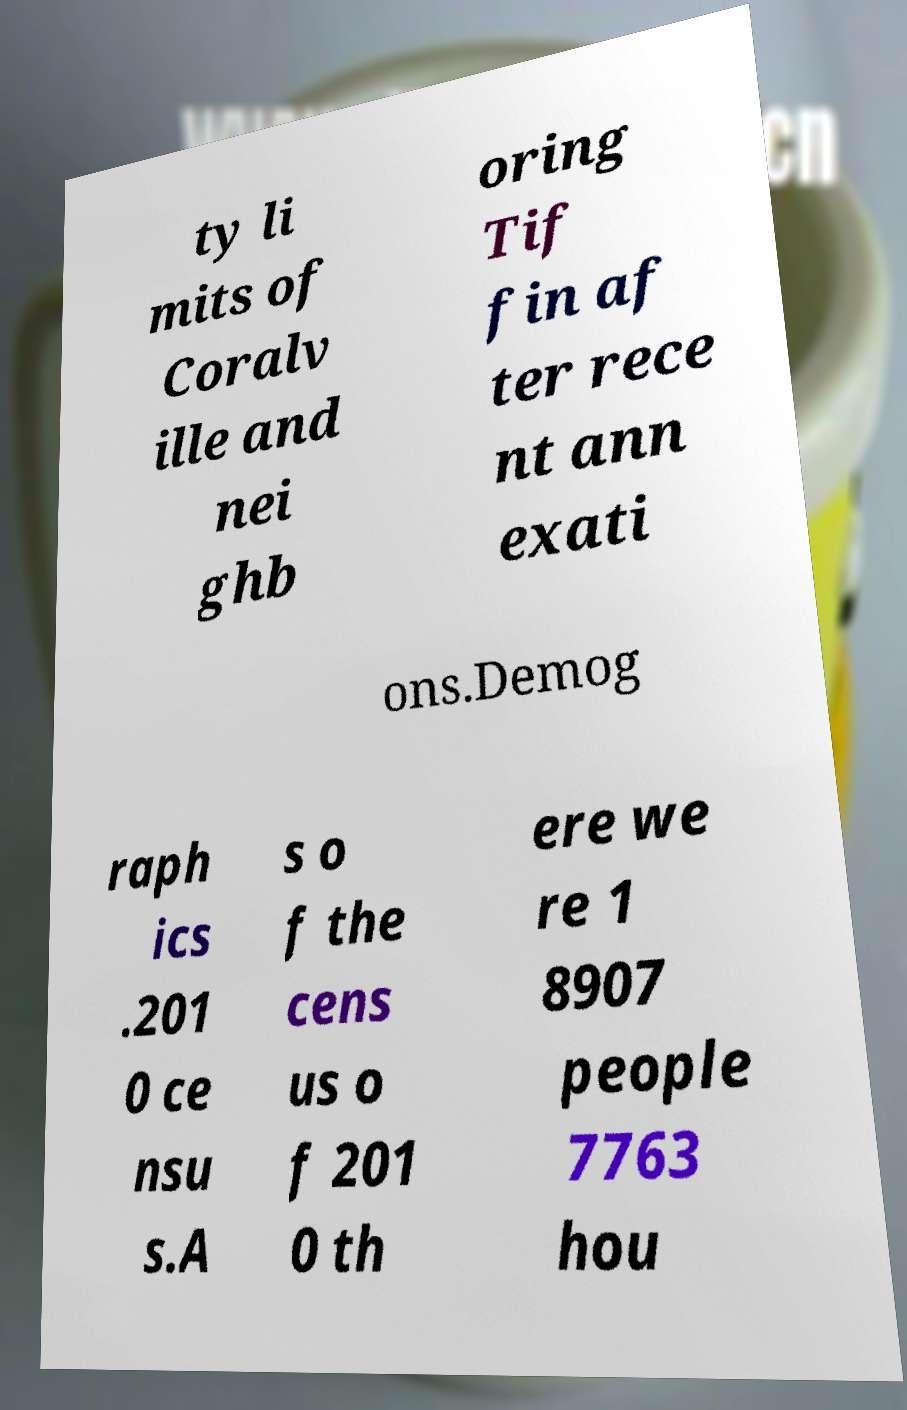For documentation purposes, I need the text within this image transcribed. Could you provide that? ty li mits of Coralv ille and nei ghb oring Tif fin af ter rece nt ann exati ons.Demog raph ics .201 0 ce nsu s.A s o f the cens us o f 201 0 th ere we re 1 8907 people 7763 hou 